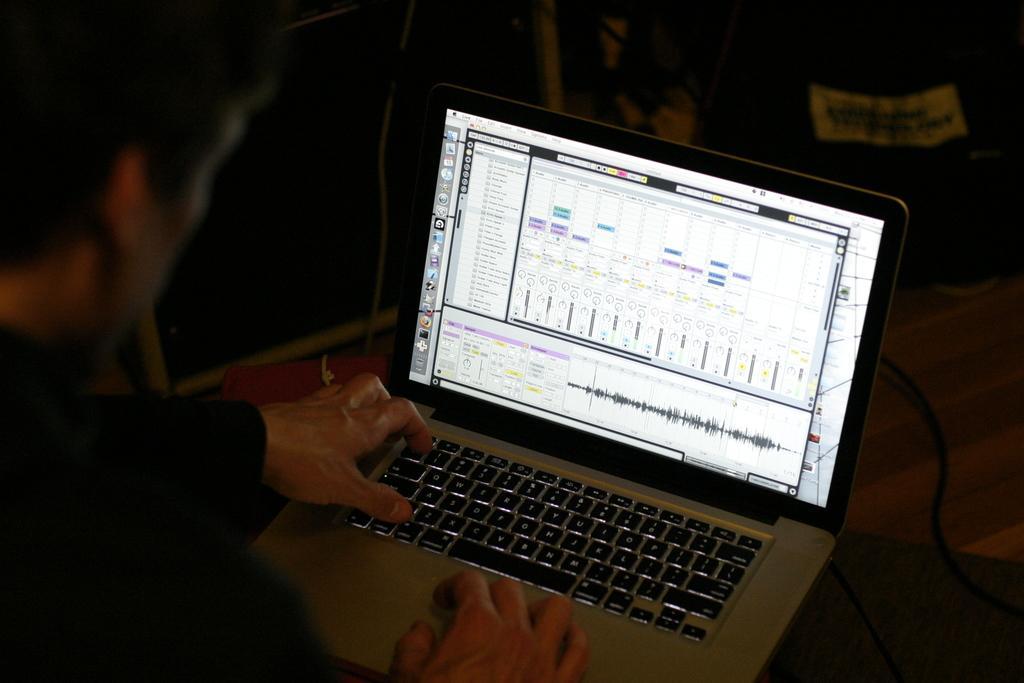How would you summarize this image in a sentence or two? In this picture there is a man and we can see laptop and cables on the platform. In the background of the image it is dark. 